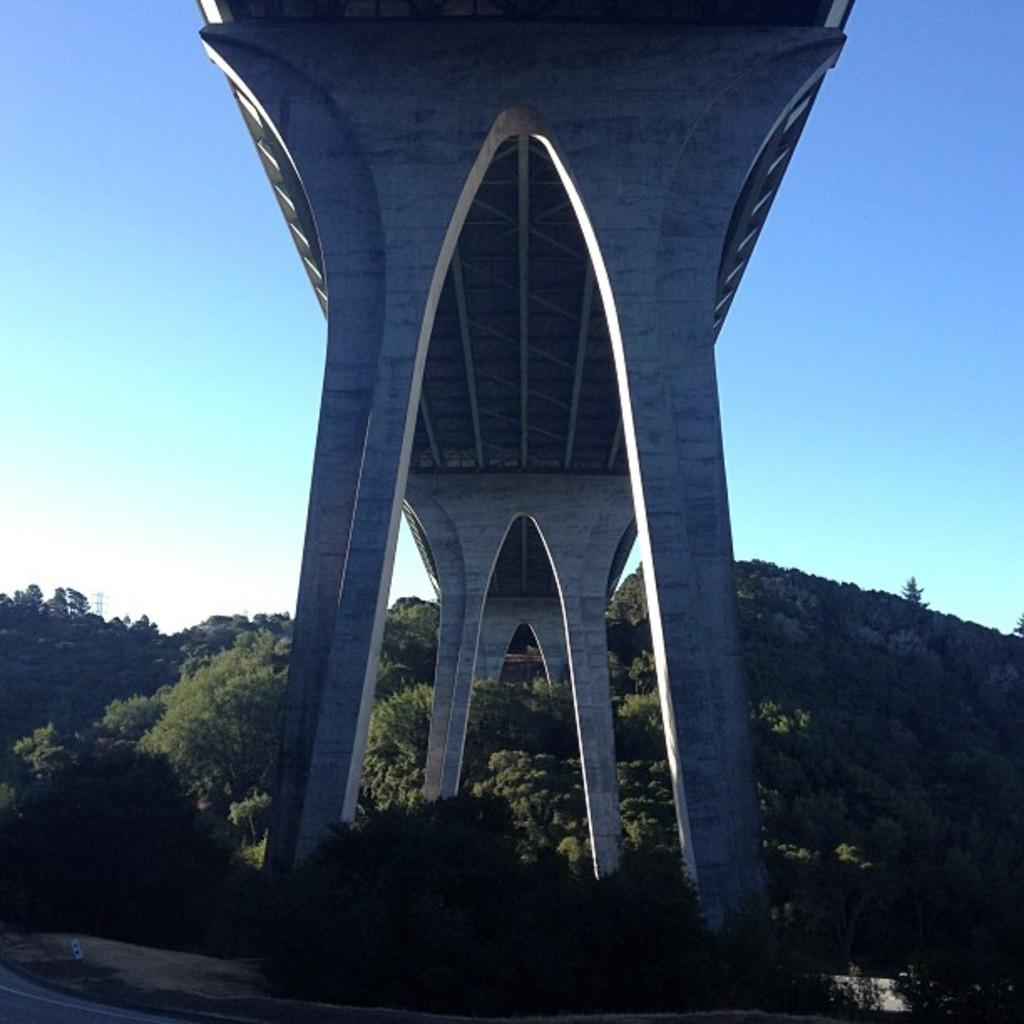What structure is the main subject of the image? There is a bridge in the image. What can be seen in the background of the image? There are trees in the background of the image. What supports the bridge in the image? There are pillars visible in the image. What is visible at the top of the image? The sky is visible at the top of the image. What type of shirt is the car wearing in the image? There is no car or shirt present in the image; it features a bridge and trees in the background. 